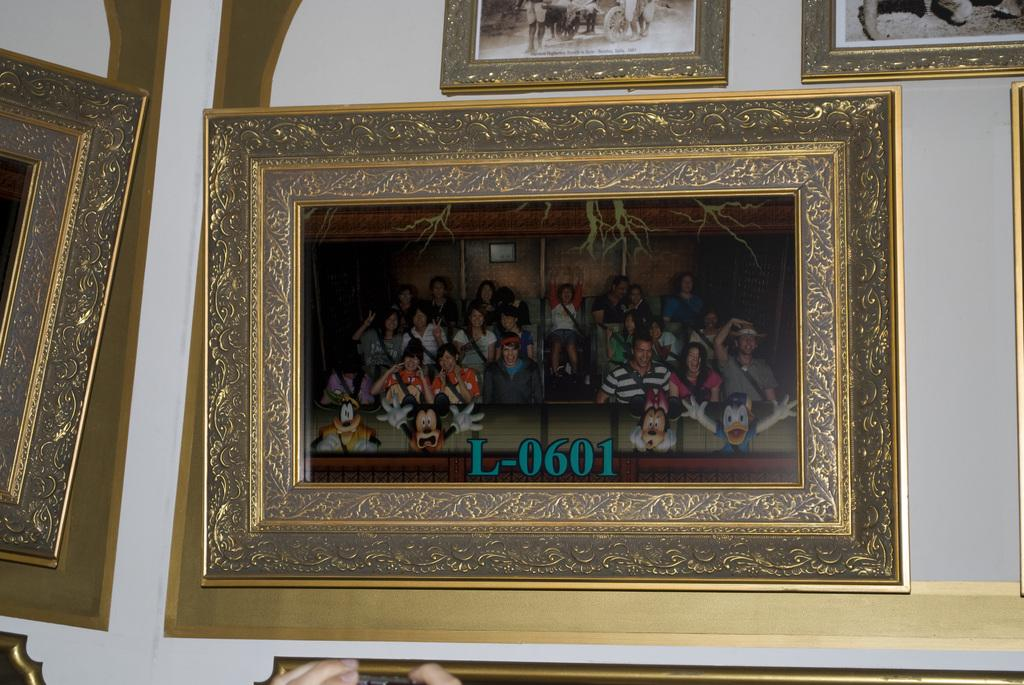<image>
Render a clear and concise summary of the photo. several framed photos on wall, one labeled L-0601 